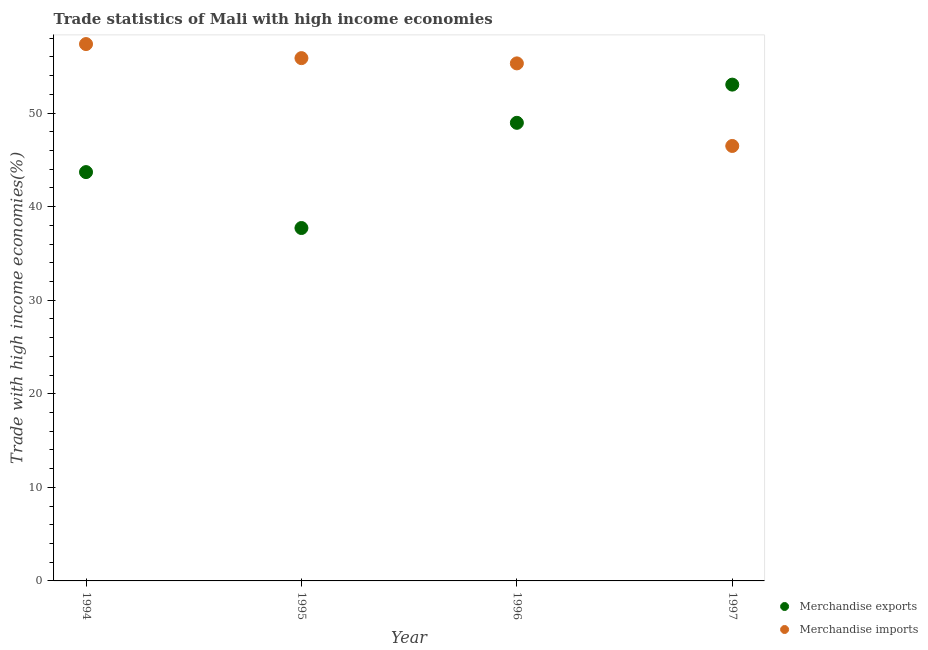How many different coloured dotlines are there?
Provide a short and direct response. 2. What is the merchandise exports in 1996?
Make the answer very short. 48.95. Across all years, what is the maximum merchandise exports?
Provide a short and direct response. 53.03. Across all years, what is the minimum merchandise exports?
Give a very brief answer. 37.71. In which year was the merchandise exports maximum?
Your response must be concise. 1997. What is the total merchandise exports in the graph?
Provide a short and direct response. 183.38. What is the difference between the merchandise exports in 1996 and that in 1997?
Keep it short and to the point. -4.08. What is the difference between the merchandise imports in 1997 and the merchandise exports in 1996?
Provide a succinct answer. -2.47. What is the average merchandise imports per year?
Keep it short and to the point. 53.75. In the year 1996, what is the difference between the merchandise exports and merchandise imports?
Your answer should be very brief. -6.35. In how many years, is the merchandise exports greater than 36 %?
Provide a short and direct response. 4. What is the ratio of the merchandise exports in 1994 to that in 1996?
Your answer should be very brief. 0.89. Is the difference between the merchandise imports in 1994 and 1996 greater than the difference between the merchandise exports in 1994 and 1996?
Provide a short and direct response. Yes. What is the difference between the highest and the second highest merchandise exports?
Your answer should be compact. 4.08. What is the difference between the highest and the lowest merchandise exports?
Provide a short and direct response. 15.32. In how many years, is the merchandise imports greater than the average merchandise imports taken over all years?
Your response must be concise. 3. Does the merchandise exports monotonically increase over the years?
Your answer should be very brief. No. Is the merchandise exports strictly less than the merchandise imports over the years?
Provide a short and direct response. No. How many dotlines are there?
Provide a succinct answer. 2. Are the values on the major ticks of Y-axis written in scientific E-notation?
Give a very brief answer. No. What is the title of the graph?
Your answer should be very brief. Trade statistics of Mali with high income economies. What is the label or title of the Y-axis?
Provide a succinct answer. Trade with high income economies(%). What is the Trade with high income economies(%) in Merchandise exports in 1994?
Your response must be concise. 43.69. What is the Trade with high income economies(%) of Merchandise imports in 1994?
Offer a terse response. 57.37. What is the Trade with high income economies(%) of Merchandise exports in 1995?
Provide a short and direct response. 37.71. What is the Trade with high income economies(%) of Merchandise imports in 1995?
Keep it short and to the point. 55.87. What is the Trade with high income economies(%) of Merchandise exports in 1996?
Ensure brevity in your answer.  48.95. What is the Trade with high income economies(%) of Merchandise imports in 1996?
Provide a short and direct response. 55.3. What is the Trade with high income economies(%) in Merchandise exports in 1997?
Provide a succinct answer. 53.03. What is the Trade with high income economies(%) of Merchandise imports in 1997?
Give a very brief answer. 46.48. Across all years, what is the maximum Trade with high income economies(%) of Merchandise exports?
Give a very brief answer. 53.03. Across all years, what is the maximum Trade with high income economies(%) of Merchandise imports?
Ensure brevity in your answer.  57.37. Across all years, what is the minimum Trade with high income economies(%) in Merchandise exports?
Provide a succinct answer. 37.71. Across all years, what is the minimum Trade with high income economies(%) of Merchandise imports?
Provide a short and direct response. 46.48. What is the total Trade with high income economies(%) of Merchandise exports in the graph?
Your response must be concise. 183.38. What is the total Trade with high income economies(%) of Merchandise imports in the graph?
Keep it short and to the point. 215.01. What is the difference between the Trade with high income economies(%) of Merchandise exports in 1994 and that in 1995?
Provide a short and direct response. 5.98. What is the difference between the Trade with high income economies(%) in Merchandise imports in 1994 and that in 1995?
Ensure brevity in your answer.  1.5. What is the difference between the Trade with high income economies(%) in Merchandise exports in 1994 and that in 1996?
Keep it short and to the point. -5.27. What is the difference between the Trade with high income economies(%) in Merchandise imports in 1994 and that in 1996?
Give a very brief answer. 2.06. What is the difference between the Trade with high income economies(%) of Merchandise exports in 1994 and that in 1997?
Make the answer very short. -9.35. What is the difference between the Trade with high income economies(%) in Merchandise imports in 1994 and that in 1997?
Your answer should be very brief. 10.89. What is the difference between the Trade with high income economies(%) of Merchandise exports in 1995 and that in 1996?
Offer a terse response. -11.24. What is the difference between the Trade with high income economies(%) of Merchandise imports in 1995 and that in 1996?
Provide a succinct answer. 0.56. What is the difference between the Trade with high income economies(%) in Merchandise exports in 1995 and that in 1997?
Your answer should be compact. -15.32. What is the difference between the Trade with high income economies(%) of Merchandise imports in 1995 and that in 1997?
Provide a short and direct response. 9.39. What is the difference between the Trade with high income economies(%) of Merchandise exports in 1996 and that in 1997?
Your response must be concise. -4.08. What is the difference between the Trade with high income economies(%) in Merchandise imports in 1996 and that in 1997?
Offer a very short reply. 8.82. What is the difference between the Trade with high income economies(%) in Merchandise exports in 1994 and the Trade with high income economies(%) in Merchandise imports in 1995?
Provide a succinct answer. -12.18. What is the difference between the Trade with high income economies(%) in Merchandise exports in 1994 and the Trade with high income economies(%) in Merchandise imports in 1996?
Make the answer very short. -11.62. What is the difference between the Trade with high income economies(%) in Merchandise exports in 1994 and the Trade with high income economies(%) in Merchandise imports in 1997?
Your answer should be compact. -2.79. What is the difference between the Trade with high income economies(%) of Merchandise exports in 1995 and the Trade with high income economies(%) of Merchandise imports in 1996?
Make the answer very short. -17.59. What is the difference between the Trade with high income economies(%) of Merchandise exports in 1995 and the Trade with high income economies(%) of Merchandise imports in 1997?
Make the answer very short. -8.77. What is the difference between the Trade with high income economies(%) in Merchandise exports in 1996 and the Trade with high income economies(%) in Merchandise imports in 1997?
Keep it short and to the point. 2.47. What is the average Trade with high income economies(%) in Merchandise exports per year?
Ensure brevity in your answer.  45.85. What is the average Trade with high income economies(%) in Merchandise imports per year?
Offer a terse response. 53.75. In the year 1994, what is the difference between the Trade with high income economies(%) of Merchandise exports and Trade with high income economies(%) of Merchandise imports?
Offer a very short reply. -13.68. In the year 1995, what is the difference between the Trade with high income economies(%) in Merchandise exports and Trade with high income economies(%) in Merchandise imports?
Offer a very short reply. -18.15. In the year 1996, what is the difference between the Trade with high income economies(%) in Merchandise exports and Trade with high income economies(%) in Merchandise imports?
Your response must be concise. -6.35. In the year 1997, what is the difference between the Trade with high income economies(%) in Merchandise exports and Trade with high income economies(%) in Merchandise imports?
Provide a succinct answer. 6.56. What is the ratio of the Trade with high income economies(%) in Merchandise exports in 1994 to that in 1995?
Make the answer very short. 1.16. What is the ratio of the Trade with high income economies(%) of Merchandise imports in 1994 to that in 1995?
Your answer should be very brief. 1.03. What is the ratio of the Trade with high income economies(%) of Merchandise exports in 1994 to that in 1996?
Offer a terse response. 0.89. What is the ratio of the Trade with high income economies(%) of Merchandise imports in 1994 to that in 1996?
Your response must be concise. 1.04. What is the ratio of the Trade with high income economies(%) in Merchandise exports in 1994 to that in 1997?
Make the answer very short. 0.82. What is the ratio of the Trade with high income economies(%) of Merchandise imports in 1994 to that in 1997?
Your answer should be compact. 1.23. What is the ratio of the Trade with high income economies(%) of Merchandise exports in 1995 to that in 1996?
Give a very brief answer. 0.77. What is the ratio of the Trade with high income economies(%) of Merchandise imports in 1995 to that in 1996?
Your response must be concise. 1.01. What is the ratio of the Trade with high income economies(%) of Merchandise exports in 1995 to that in 1997?
Keep it short and to the point. 0.71. What is the ratio of the Trade with high income economies(%) in Merchandise imports in 1995 to that in 1997?
Offer a very short reply. 1.2. What is the ratio of the Trade with high income economies(%) in Merchandise exports in 1996 to that in 1997?
Your answer should be very brief. 0.92. What is the ratio of the Trade with high income economies(%) of Merchandise imports in 1996 to that in 1997?
Make the answer very short. 1.19. What is the difference between the highest and the second highest Trade with high income economies(%) in Merchandise exports?
Provide a short and direct response. 4.08. What is the difference between the highest and the second highest Trade with high income economies(%) of Merchandise imports?
Give a very brief answer. 1.5. What is the difference between the highest and the lowest Trade with high income economies(%) in Merchandise exports?
Your response must be concise. 15.32. What is the difference between the highest and the lowest Trade with high income economies(%) of Merchandise imports?
Your answer should be compact. 10.89. 